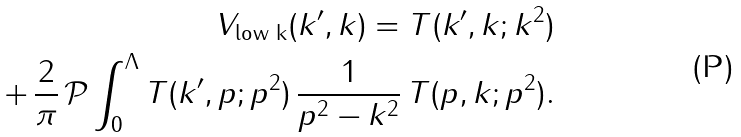<formula> <loc_0><loc_0><loc_500><loc_500>V _ { \text {low k} } ( k ^ { \prime } , k ) = T ( k ^ { \prime } , k ; k ^ { 2 } ) \\ + \, \frac { 2 } { \pi } \, \mathcal { P } \int _ { 0 } ^ { \Lambda } T ( k ^ { \prime } , p ; p ^ { 2 } ) \, \frac { 1 } { p ^ { 2 } - k ^ { 2 } } \, T ( p , k ; p ^ { 2 } ) .</formula> 